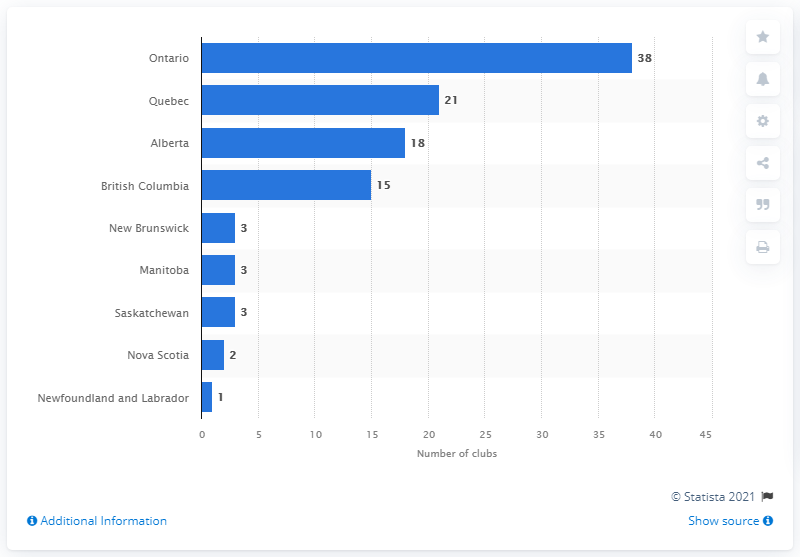Outline some significant characteristics in this image. As of December 2020, there were 38 warehouse clubs in Ontario. 